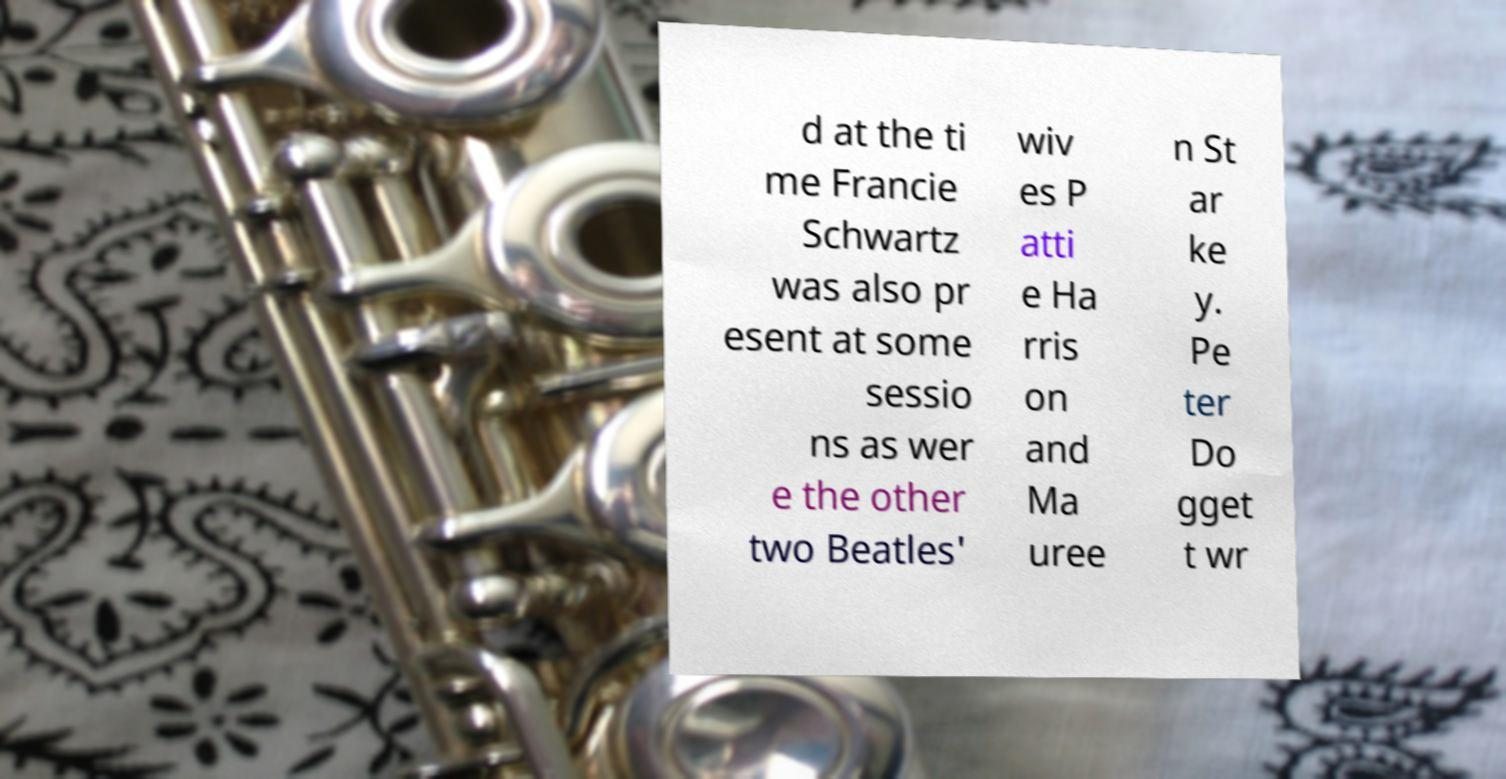For documentation purposes, I need the text within this image transcribed. Could you provide that? d at the ti me Francie Schwartz was also pr esent at some sessio ns as wer e the other two Beatles' wiv es P atti e Ha rris on and Ma uree n St ar ke y. Pe ter Do gget t wr 